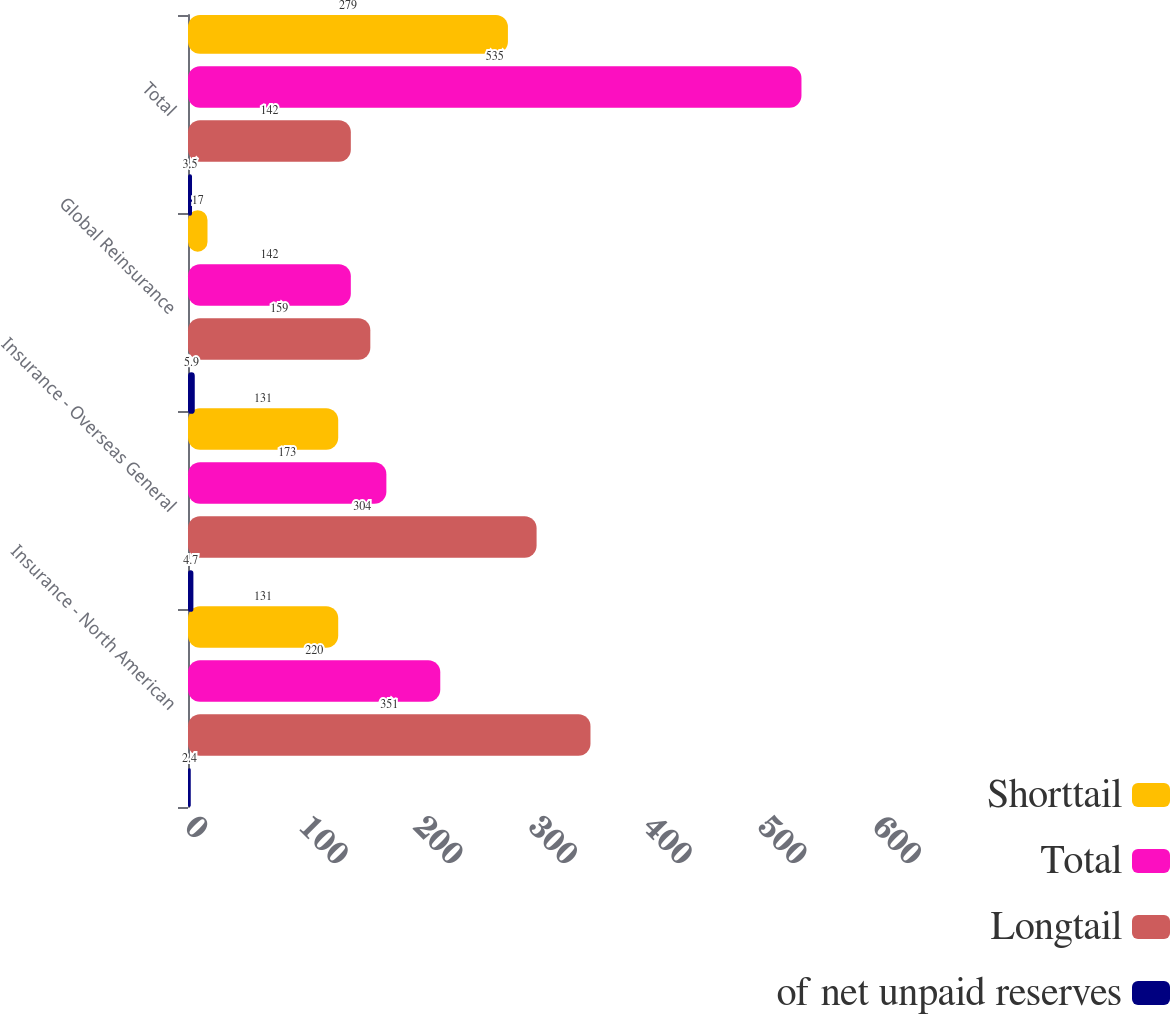Convert chart to OTSL. <chart><loc_0><loc_0><loc_500><loc_500><stacked_bar_chart><ecel><fcel>Insurance - North American<fcel>Insurance - Overseas General<fcel>Global Reinsurance<fcel>Total<nl><fcel>Shorttail<fcel>131<fcel>131<fcel>17<fcel>279<nl><fcel>Total<fcel>220<fcel>173<fcel>142<fcel>535<nl><fcel>Longtail<fcel>351<fcel>304<fcel>159<fcel>142<nl><fcel>of net unpaid reserves<fcel>2.4<fcel>4.7<fcel>5.9<fcel>3.5<nl></chart> 